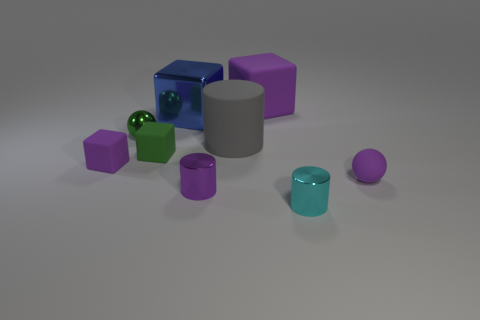Do the sphere that is behind the small purple matte block and the cylinder that is behind the tiny purple rubber sphere have the same color?
Offer a terse response. No. Are any cyan metal cylinders visible?
Your answer should be very brief. Yes. There is a thing that is the same color as the metallic ball; what is it made of?
Your answer should be very brief. Rubber. What is the size of the matte thing that is in front of the tiny purple thing that is behind the tiny ball on the right side of the small green metal thing?
Give a very brief answer. Small. Does the blue shiny thing have the same shape as the object on the right side of the tiny cyan metallic thing?
Your response must be concise. No. Are there any other cubes of the same color as the large shiny block?
Provide a succinct answer. No. What number of blocks are either large metallic objects or tiny cyan objects?
Offer a very short reply. 1. Is there a yellow rubber object of the same shape as the blue thing?
Provide a short and direct response. No. How many other objects are the same color as the large metallic object?
Your answer should be very brief. 0. Is the number of rubber cylinders in front of the tiny purple matte block less than the number of small purple things?
Make the answer very short. Yes. 